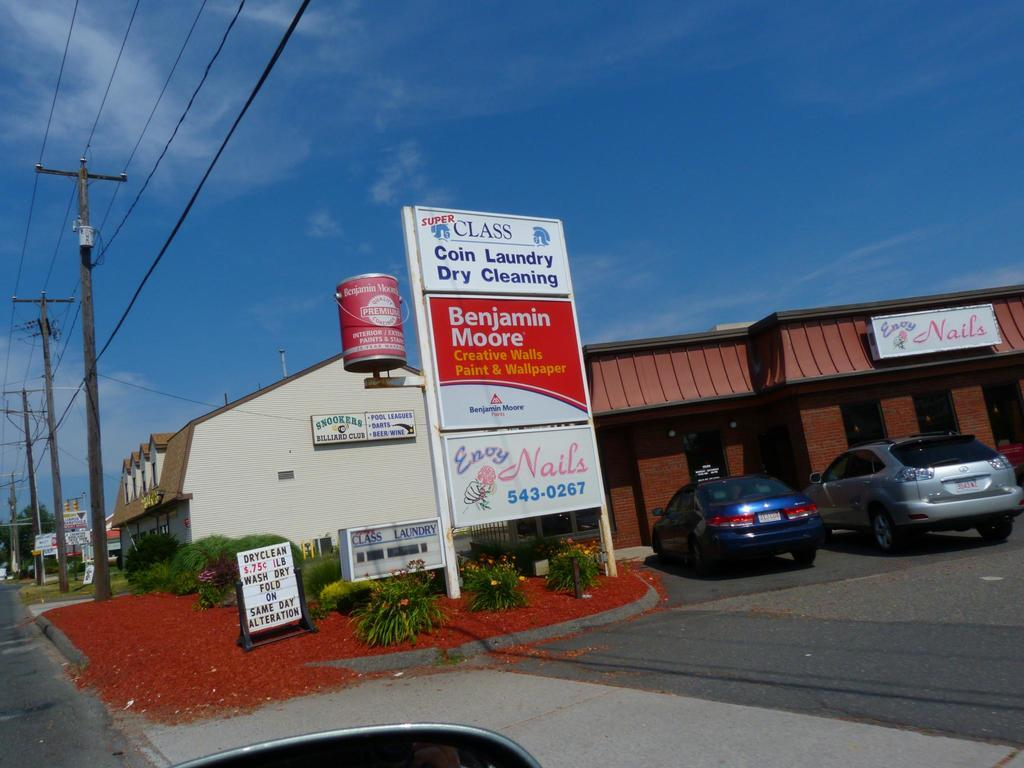<image>
Relay a brief, clear account of the picture shown. a shopping plaza with a coin laundry establishment in it 